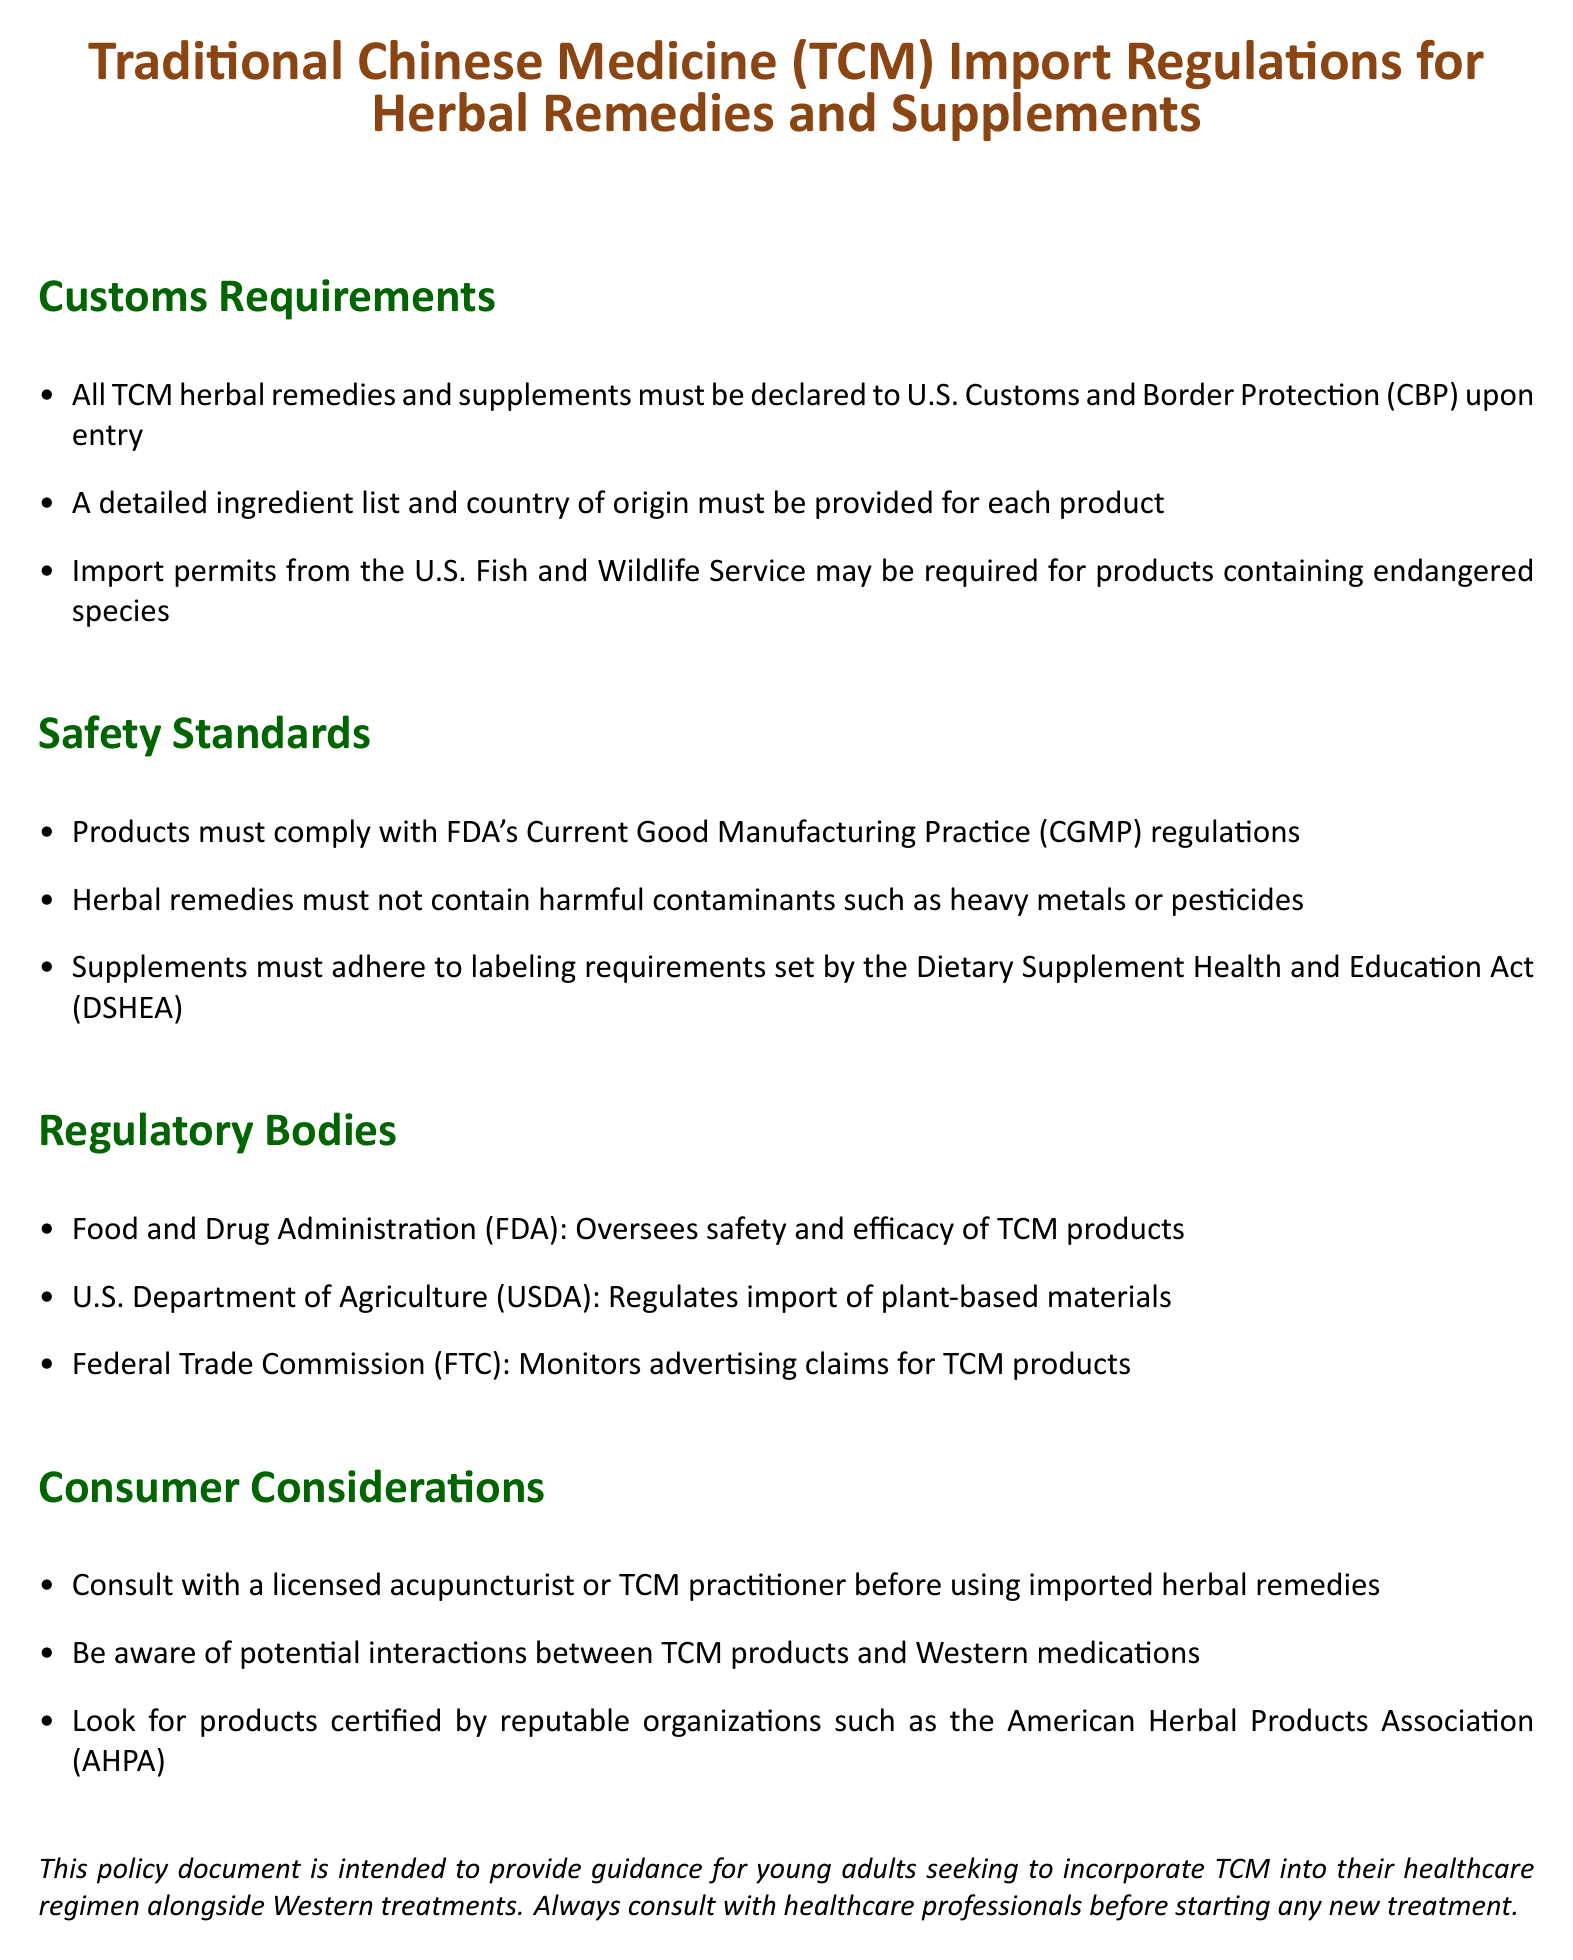What must be provided for each product upon entry? According to the document, a detailed ingredient list and country of origin must be provided for each product when imported.
Answer: detailed ingredient list and country of origin Which organization oversees the safety and efficacy of TCM products? The document states that the Food and Drug Administration (FDA) oversees the safety and efficacy of TCM products.
Answer: Food and Drug Administration (FDA) What is required for herbal remedies to comply with safety standards? The document indicates that herbal remedies must not contain harmful contaminants such as heavy metals or pesticides to comply with safety standards.
Answer: harmful contaminants such as heavy metals or pesticides What act sets the labeling requirements for supplements? The Dietary Supplement Health and Education Act (DSHEA) is mentioned in the document as the act that sets labeling requirements for supplements.
Answer: Dietary Supplement Health and Education Act (DSHEA) Why should consumers consult with a licensed acupuncturist? The document advises consulting with a licensed acupuncturist or TCM practitioner to avoid potential interactions with Western medications.
Answer: potential interactions with Western medications What may be required for products containing endangered species? The document states that import permits from the U.S. Fish and Wildlife Service may be required for such products.
Answer: import permits from the U.S. Fish and Wildlife Service Which organization monitors advertising claims for TCM products? According to the document, the Federal Trade Commission (FTC) monitors advertising claims for TCM products.
Answer: Federal Trade Commission (FTC) 